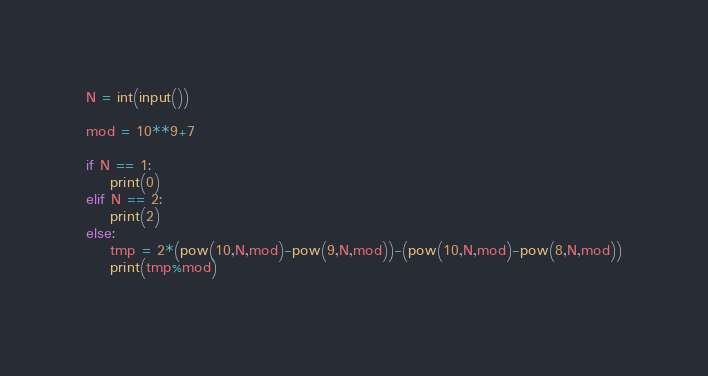Convert code to text. <code><loc_0><loc_0><loc_500><loc_500><_Python_>N = int(input())

mod = 10**9+7

if N == 1:
    print(0)
elif N == 2:
    print(2)
else:
    tmp = 2*(pow(10,N,mod)-pow(9,N,mod))-(pow(10,N,mod)-pow(8,N,mod))
    print(tmp%mod)
    </code> 